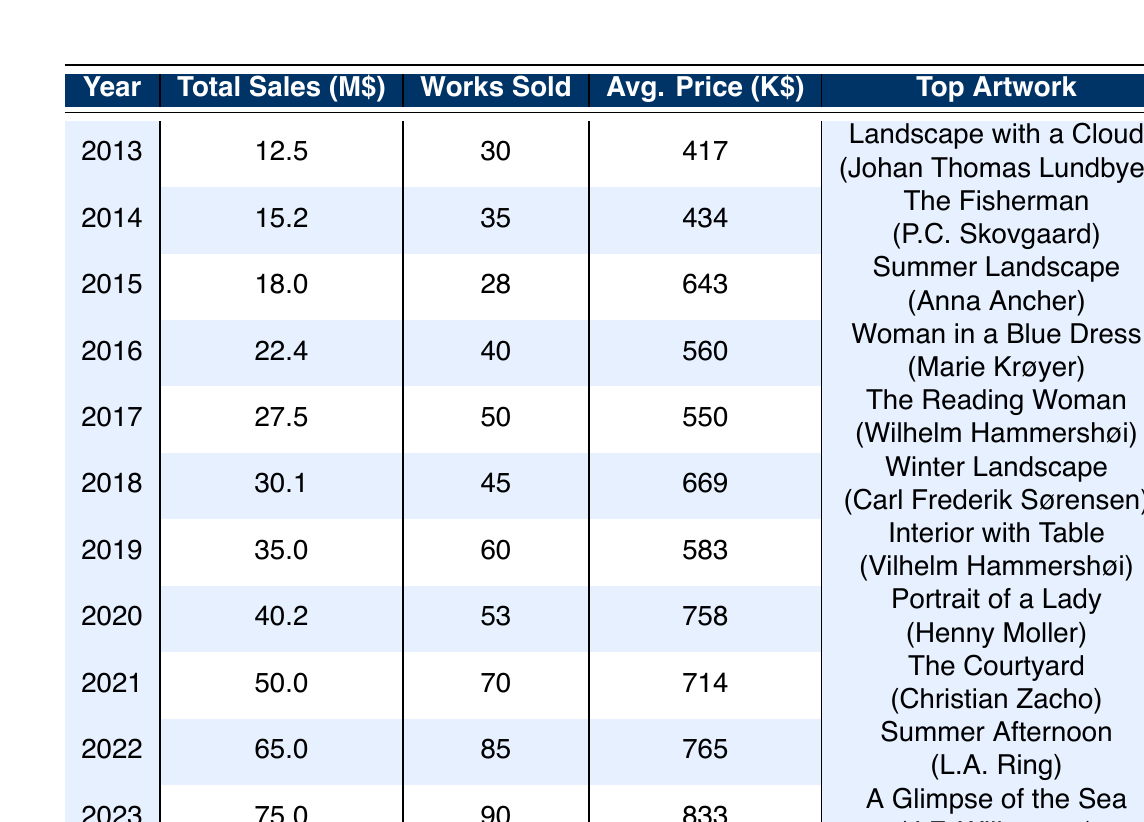What was the total sales in 2019? The table shows the total sales for each year. For 2019, the total sales are listed as 35.0 million dollars.
Answer: 35.0 million dollars Which artist had the highest selling artwork in 2021? In 2021, the table indicates that the high selling artwork is "The Courtyard" by Christian Zacho, with a sale price of 15.0 million dollars.
Answer: Christian Zacho What was the average price of artworks sold in 2020? From the table, the average price of artworks sold in 2020 is given directly as 758 thousand dollars.
Answer: 758 thousand dollars Which year had the highest number of works sold, and how many were sold? Looking through the table, the year 2022 shows the highest number of works sold, which is 85.
Answer: 2022, 85 works What is the total sales increase from 2018 to 2023? To find the total sales increase, subtract the 2018 total sales (30.1 million dollars) from the 2023 total sales (75.0 million dollars). The increase is 75.0 - 30.1 = 44.9 million dollars.
Answer: 44.9 million dollars Was the average price of artworks in 2022 higher than in 2019? The average price for 2022 is 764 thousand dollars, while for 2019, it is 583 thousand dollars. Since 764 > 583, the statement is true.
Answer: Yes In which year did the top artwork sell for 10.0 million dollars? Looking at the table, the high selling artwork for 2020 is "Portrait of a Lady" by Henny Moller, sold for 10.0 million dollars. Therefore, it happened in 2020.
Answer: 2020 What was the average price across all sales from 2013 to 2023? To calculate the average price, sum the average prices in the table for each year: (417 + 434 + 643 + 560 + 550 + 669 + 583 + 758 + 714 + 765 + 833) / 11 = 619.91 (approximately).
Answer: 620 thousand dollars Was there an increase in total sales every year from 2013 to 2023? By checking each year, we find that total sales consistently increased from 2013 (12.5 million) to 2023 (75.0 million), indicating a yes for this statement.
Answer: Yes 